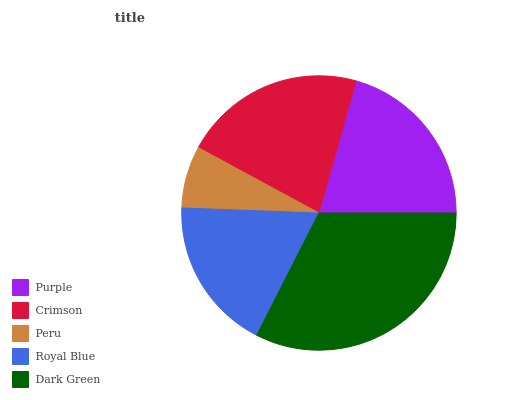Is Peru the minimum?
Answer yes or no. Yes. Is Dark Green the maximum?
Answer yes or no. Yes. Is Crimson the minimum?
Answer yes or no. No. Is Crimson the maximum?
Answer yes or no. No. Is Crimson greater than Purple?
Answer yes or no. Yes. Is Purple less than Crimson?
Answer yes or no. Yes. Is Purple greater than Crimson?
Answer yes or no. No. Is Crimson less than Purple?
Answer yes or no. No. Is Purple the high median?
Answer yes or no. Yes. Is Purple the low median?
Answer yes or no. Yes. Is Peru the high median?
Answer yes or no. No. Is Peru the low median?
Answer yes or no. No. 